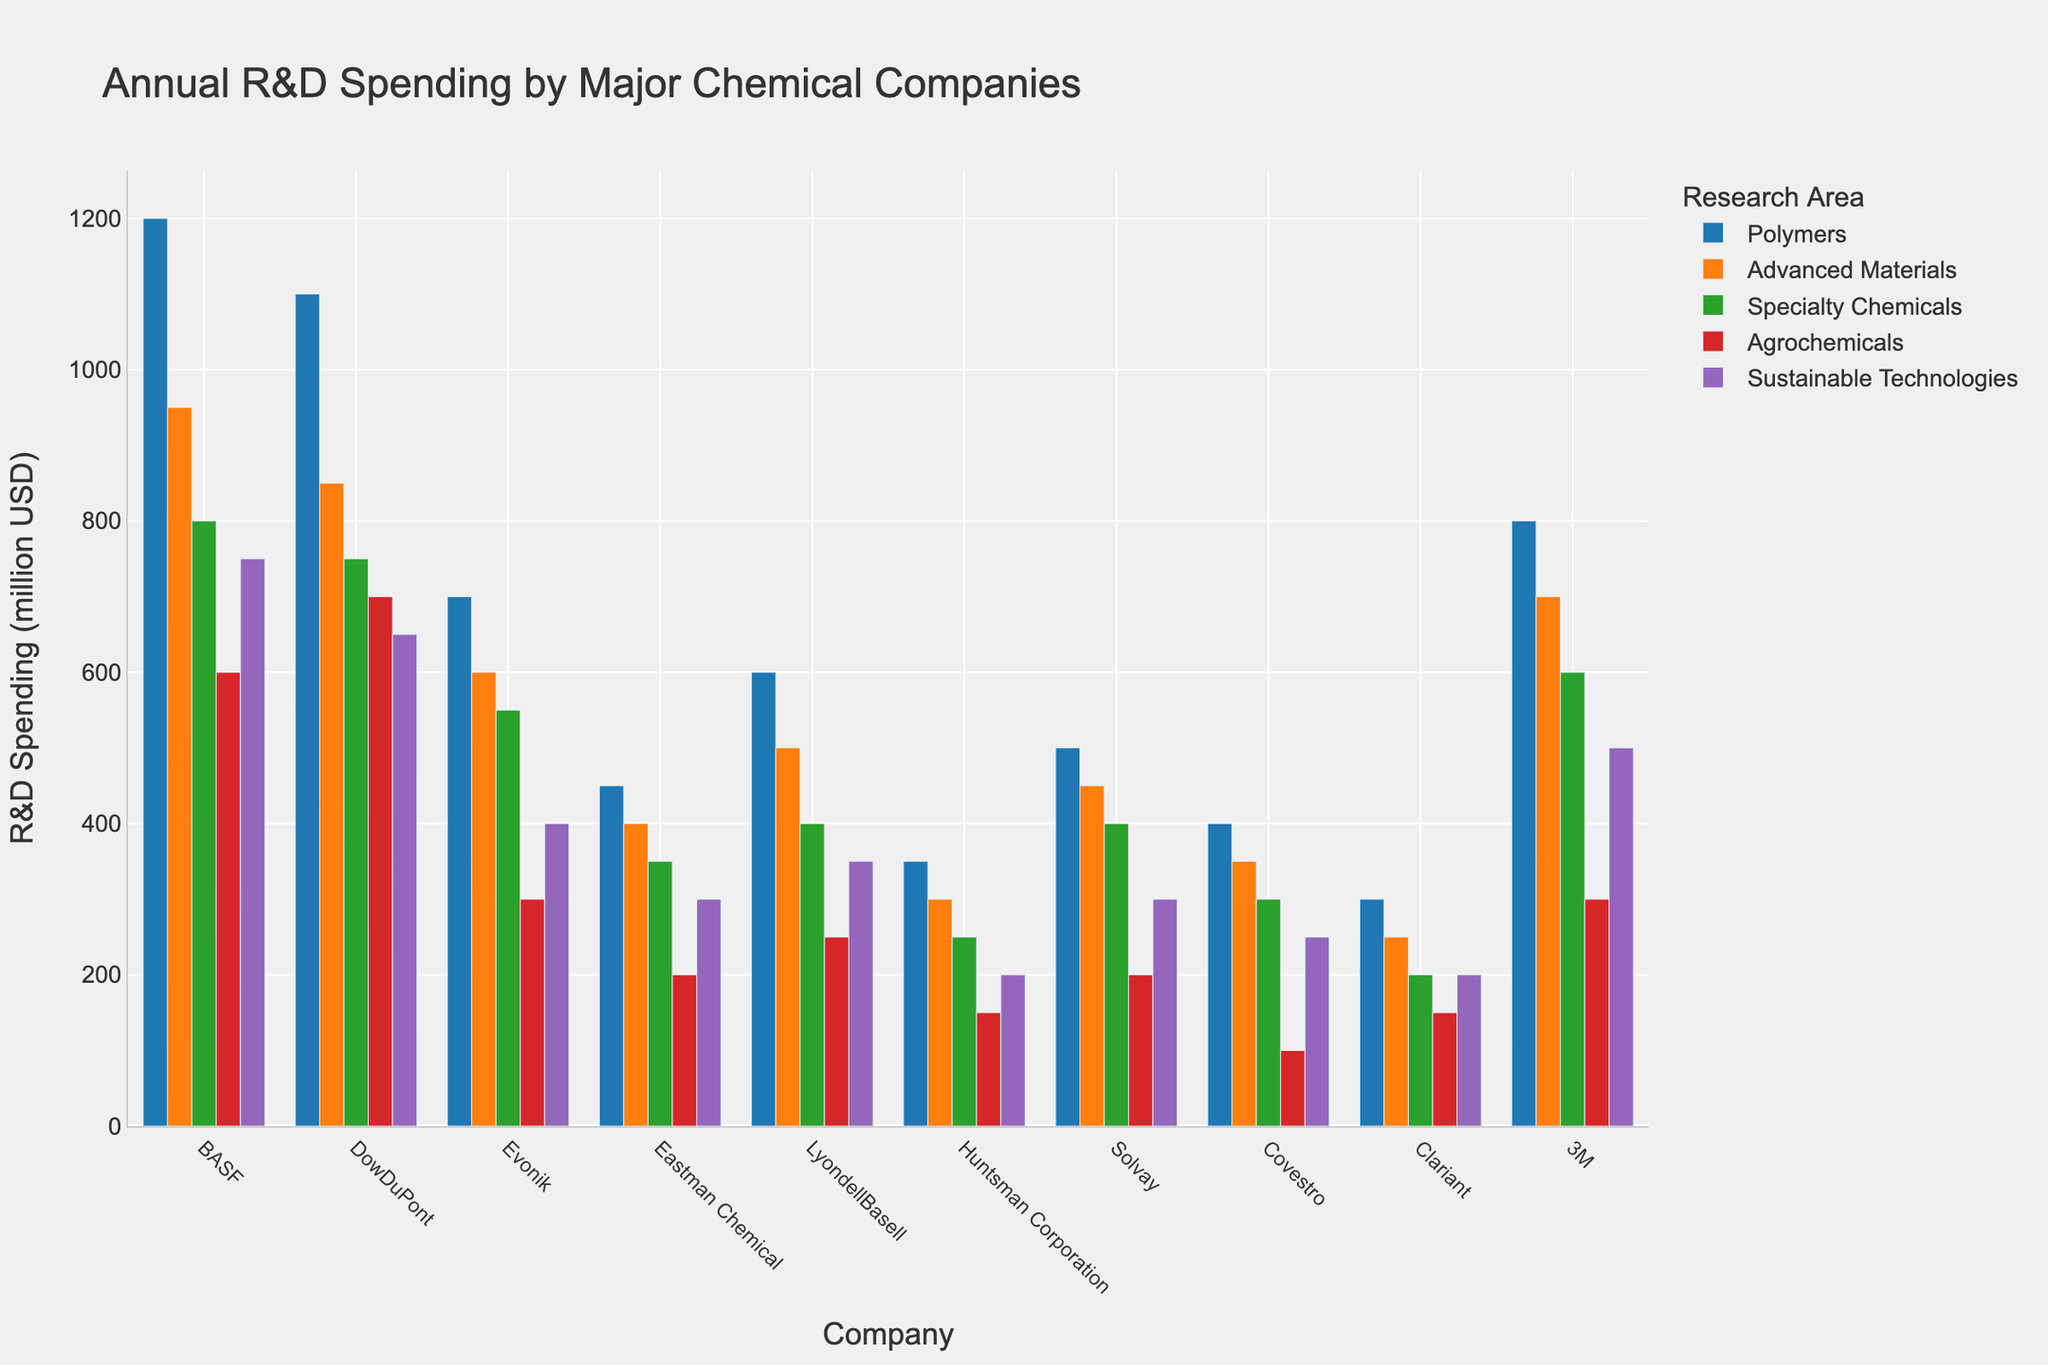Which company has the highest R&D spending on Polymers? Look at the height of the bars under the Polymers category for each company and identify which one is the tallest. BASF's bar is the tallest in the Polymers category.
Answer: BASF Which research area does Eastman Chemical spend the least on? For Eastman Chemical, compare the heights of the bars representing spending in each research area. The Agrochemicals bar is the shortest.
Answer: Agrochemicals How much more does 3M spend on Advanced Materials compared to Evonik? Look at the bars for Advanced Materials spending for both 3M and Evonik. 3M spends 700 million USD and Evonik spends 600 million USD. The difference is 700 - 600.
Answer: 100 million USD Which company has the smallest total R&D spending on Polymers and Advanced Materials combined? Sum the spending on Polymers and Advanced Materials for each company and find the smallest total. Example for Huntsman Corporation: 350 (Polymers) + 300 (Advanced Materials) = 650. Do this for all companies, and Huntsman Corporation has the smallest total.
Answer: Huntsman Corporation How does BASF's spending on Sustainable Technologies compare to that of LyondellBasell? Look at the bars representing spending on Sustainable Technologies for BASF and LyondellBasell. BASF spends 750 million USD, while LyondellBasell spends 350 million USD. Compare these values.
Answer: BASF spends more What is the average spending on Specialty Chemicals by the companies? Sum the spending on Specialty Chemicals for all companies and divide by the number of companies. (800 + 750 + 550 + 350 + 400 + 250 + 400 + 300 + 200 + 600) / 10 = 4600 / 10.
Answer: 460 million USD How many companies spend more than 500 million USD on Advanced Materials? Look at the bars for Advanced Materials spending for each company and count those with spending above 500 million USD (BASF, DowDuPont, 3M).
Answer: 3 companies What is the total R&D spending by Solvay in all research areas? Sum the heights of all the bars representing Solvay's spending in each research area: 500 + 450 + 400 + 200 + 300.
Answer: 1850 million USD Is the spending on Agrochemicals by Huntsman Corporation greater than that of Clariant? Compare the heights of the Agrochemicals bars for Huntsman Corporation and Clariant. Huntsman Corporation spends 150 million USD and Clariant spends 150 million USD.
Answer: They are equal Which company has the highest total spending in Sustainable Technologies and Agrochemicals combined? Sum the spending on Sustainable Technologies and Agrochemicals for each company, then find the highest total. For BASF: 750 (Sustainable) + 600 (Agrochemicals) = 1350. Repeat this for each company to find the highest.
Answer: BASF 